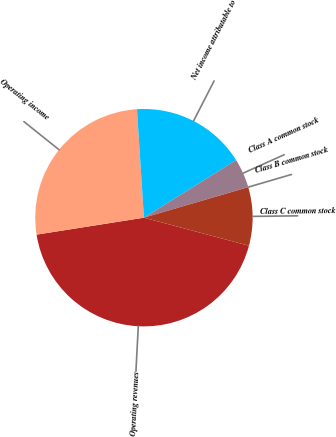Convert chart. <chart><loc_0><loc_0><loc_500><loc_500><pie_chart><fcel>Operating revenues<fcel>Operating income<fcel>Net income attributable to<fcel>Class A common stock<fcel>Class B common stock<fcel>Class C common stock<nl><fcel>43.36%<fcel>26.47%<fcel>17.13%<fcel>4.35%<fcel>0.01%<fcel>8.68%<nl></chart> 